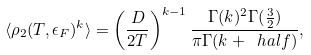Convert formula to latex. <formula><loc_0><loc_0><loc_500><loc_500>\langle \rho _ { 2 } ( T , \epsilon _ { F } ) ^ { k } \rangle = \left ( \frac { D } { 2 T } \right ) ^ { k - 1 } \frac { \Gamma ( k ) ^ { 2 } \Gamma ( \frac { 3 } { 2 } ) } { \pi \Gamma ( k + \ h a l f ) } ,</formula> 